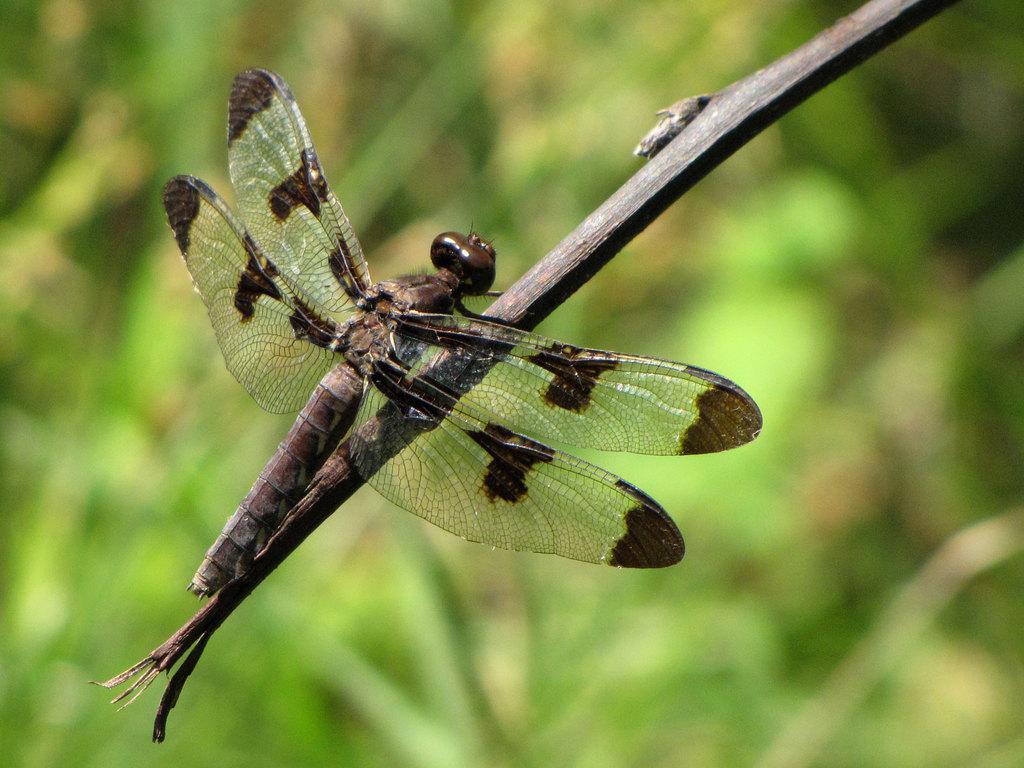In one or two sentences, can you explain what this image depicts? In the center of the picture there is a dragonfly on a stem. The background is blurred. In the background there is greenery. 